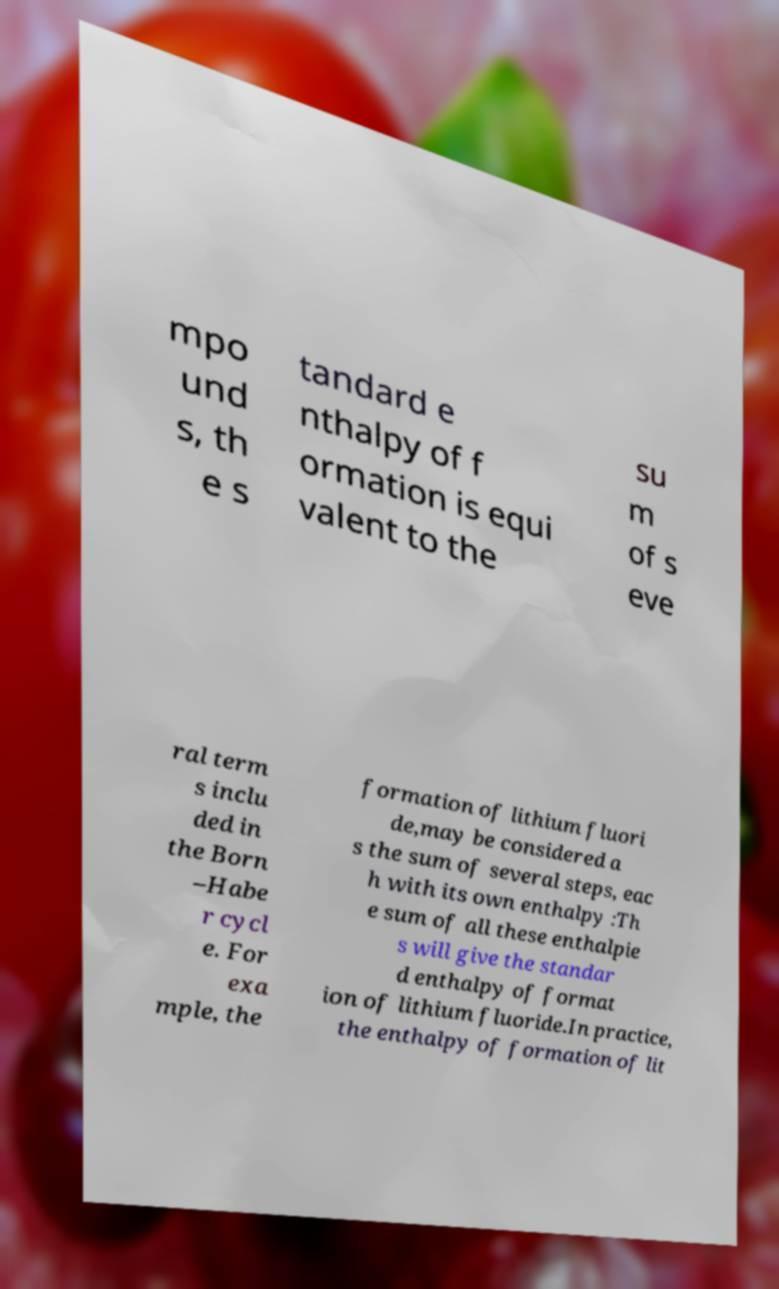For documentation purposes, I need the text within this image transcribed. Could you provide that? mpo und s, th e s tandard e nthalpy of f ormation is equi valent to the su m of s eve ral term s inclu ded in the Born –Habe r cycl e. For exa mple, the formation of lithium fluori de,may be considered a s the sum of several steps, eac h with its own enthalpy :Th e sum of all these enthalpie s will give the standar d enthalpy of format ion of lithium fluoride.In practice, the enthalpy of formation of lit 